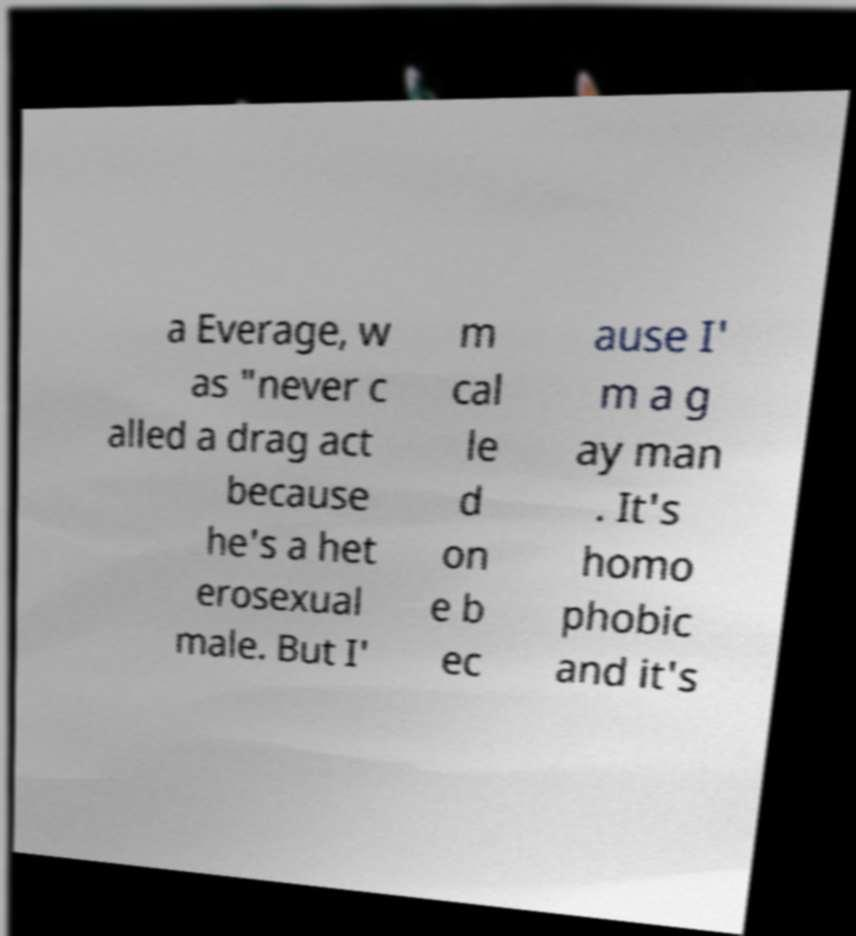What messages or text are displayed in this image? I need them in a readable, typed format. a Everage, w as "never c alled a drag act because he's a het erosexual male. But I' m cal le d on e b ec ause I' m a g ay man . It's homo phobic and it's 